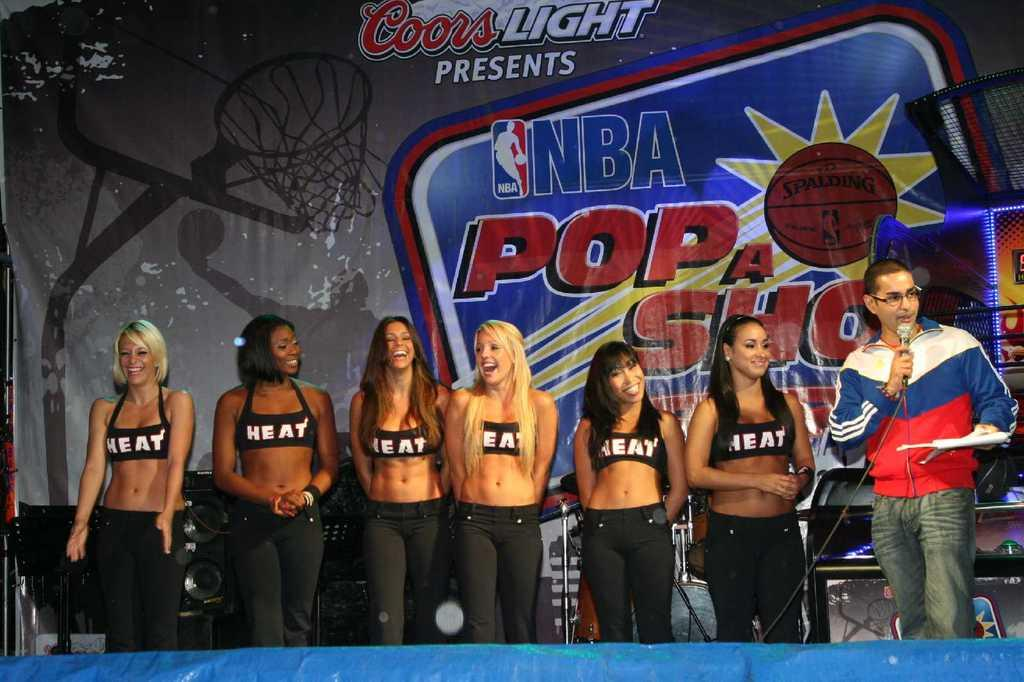<image>
Describe the image concisely. NBA event for the basketball team Heat have models standing next to the host. 